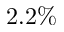<formula> <loc_0><loc_0><loc_500><loc_500>2 . 2 \%</formula> 